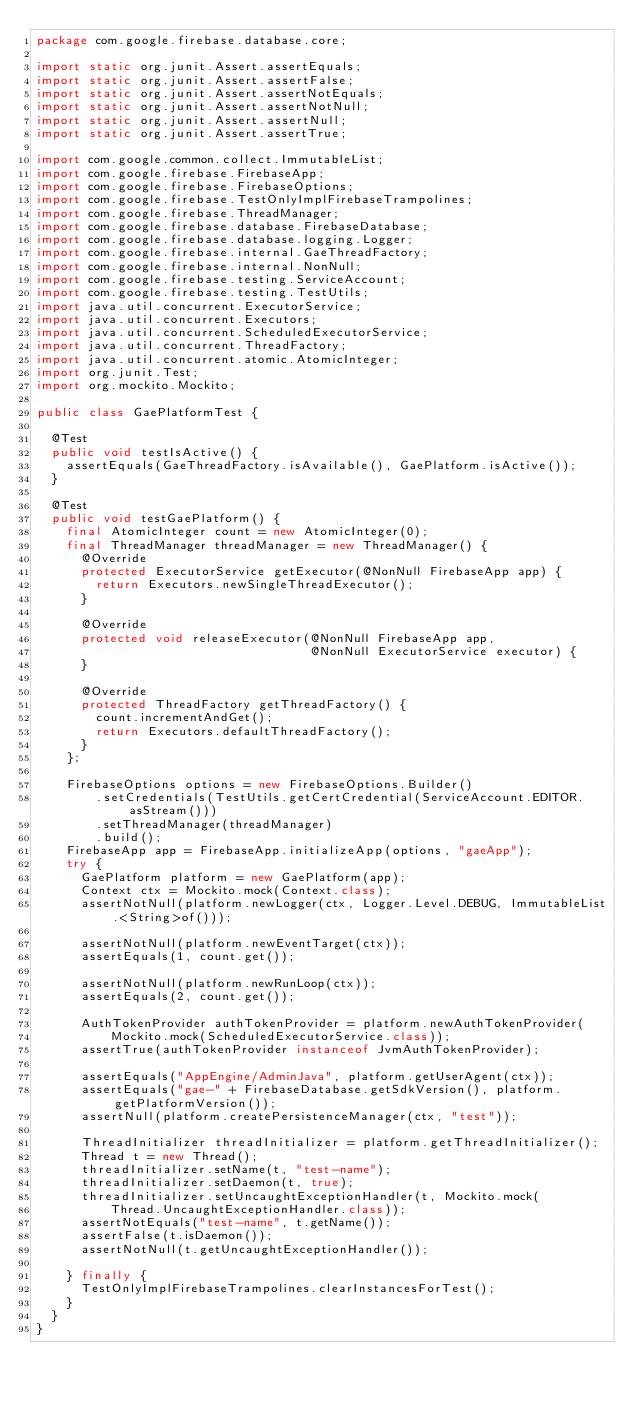Convert code to text. <code><loc_0><loc_0><loc_500><loc_500><_Java_>package com.google.firebase.database.core;

import static org.junit.Assert.assertEquals;
import static org.junit.Assert.assertFalse;
import static org.junit.Assert.assertNotEquals;
import static org.junit.Assert.assertNotNull;
import static org.junit.Assert.assertNull;
import static org.junit.Assert.assertTrue;

import com.google.common.collect.ImmutableList;
import com.google.firebase.FirebaseApp;
import com.google.firebase.FirebaseOptions;
import com.google.firebase.TestOnlyImplFirebaseTrampolines;
import com.google.firebase.ThreadManager;
import com.google.firebase.database.FirebaseDatabase;
import com.google.firebase.database.logging.Logger;
import com.google.firebase.internal.GaeThreadFactory;
import com.google.firebase.internal.NonNull;
import com.google.firebase.testing.ServiceAccount;
import com.google.firebase.testing.TestUtils;
import java.util.concurrent.ExecutorService;
import java.util.concurrent.Executors;
import java.util.concurrent.ScheduledExecutorService;
import java.util.concurrent.ThreadFactory;
import java.util.concurrent.atomic.AtomicInteger;
import org.junit.Test;
import org.mockito.Mockito;

public class GaePlatformTest {

  @Test
  public void testIsActive() {
    assertEquals(GaeThreadFactory.isAvailable(), GaePlatform.isActive());
  }

  @Test
  public void testGaePlatform() {
    final AtomicInteger count = new AtomicInteger(0);
    final ThreadManager threadManager = new ThreadManager() {
      @Override
      protected ExecutorService getExecutor(@NonNull FirebaseApp app) {
        return Executors.newSingleThreadExecutor();
      }

      @Override
      protected void releaseExecutor(@NonNull FirebaseApp app,
                                     @NonNull ExecutorService executor) {
      }

      @Override
      protected ThreadFactory getThreadFactory() {
        count.incrementAndGet();
        return Executors.defaultThreadFactory();
      }
    };

    FirebaseOptions options = new FirebaseOptions.Builder()
        .setCredentials(TestUtils.getCertCredential(ServiceAccount.EDITOR.asStream()))
        .setThreadManager(threadManager)
        .build();
    FirebaseApp app = FirebaseApp.initializeApp(options, "gaeApp");
    try {
      GaePlatform platform = new GaePlatform(app);
      Context ctx = Mockito.mock(Context.class);
      assertNotNull(platform.newLogger(ctx, Logger.Level.DEBUG, ImmutableList.<String>of()));

      assertNotNull(platform.newEventTarget(ctx));
      assertEquals(1, count.get());

      assertNotNull(platform.newRunLoop(ctx));
      assertEquals(2, count.get());

      AuthTokenProvider authTokenProvider = platform.newAuthTokenProvider(
          Mockito.mock(ScheduledExecutorService.class));
      assertTrue(authTokenProvider instanceof JvmAuthTokenProvider);

      assertEquals("AppEngine/AdminJava", platform.getUserAgent(ctx));
      assertEquals("gae-" + FirebaseDatabase.getSdkVersion(), platform.getPlatformVersion());
      assertNull(platform.createPersistenceManager(ctx, "test"));

      ThreadInitializer threadInitializer = platform.getThreadInitializer();
      Thread t = new Thread();
      threadInitializer.setName(t, "test-name");
      threadInitializer.setDaemon(t, true);
      threadInitializer.setUncaughtExceptionHandler(t, Mockito.mock(
          Thread.UncaughtExceptionHandler.class));
      assertNotEquals("test-name", t.getName());
      assertFalse(t.isDaemon());
      assertNotNull(t.getUncaughtExceptionHandler());

    } finally {
      TestOnlyImplFirebaseTrampolines.clearInstancesForTest();
    }
  }
}
</code> 